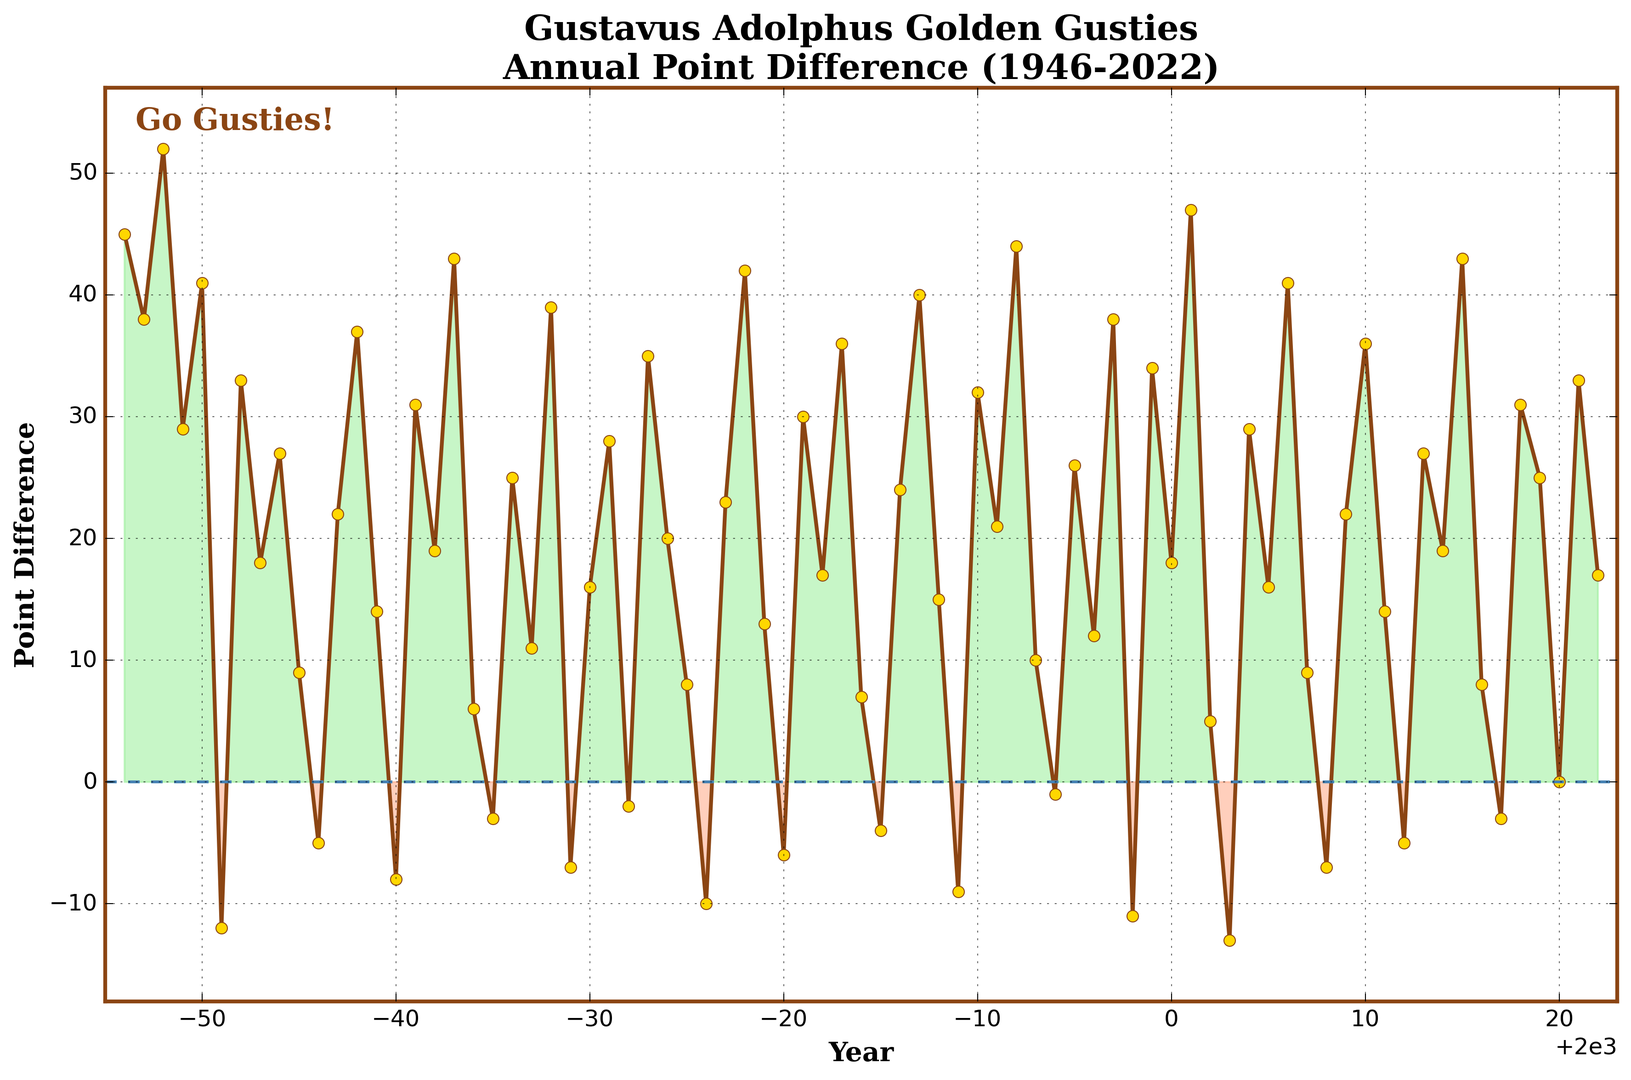What was the highest annual point difference achieved by the Gustavus Adolphus Golden Gusties from 1946 to 2022? Identify the highest point on the line chart and note the value. The highest point difference is in the year 2001 with a value of 47.
Answer: 47 Which years did the Gustavus Adolphus Golden Gusties have a negative point difference? Look for years where the line chart is below the zero-point line (indicated by shading in red). These years are 1951, 1956, 1960, 1965, 1969, 1972, 1976, 1980, 1985, 1989, 1994, 1998, 2003, 2008, 2012, and 2017.
Answer: 16 What is the average point difference from 1960 to 1970? List the point differences for each year within the range and calculate their average: (-8 + 31 + 19 + 43 + 6 + -3 + 25 + 11 + 39 + -7 + 16) / 11 = 15.91.
Answer: 15.91 In which years did the Gustavus Adolphus Golden Gusties have exactly zero point difference? Identify the year where the point difference is zero. This occurs in 2020.
Answer: 1 How many times did the point difference exceed 40? Count the peaks in the chart that exceed the 40-point difference line. These years are 1948, 1950, 1963, 2001, 2006, 2021.
Answer: 6 What is the difference between the highest positive point difference and the lowest negative point difference? Identify the highest positive (2001, 47) and the lowest negative (2003, -13) point differences and subtract the negative from the positive value: 47 - (-13) = 60.
Answer: 60 Which year had the greatest one-year increase in point difference? Compare point differences of consecutive years and find the greatest increase. From 2000 to 2001, there was an increase from 18 to 47, an increase of 29.
Answer: 2001 Was there any period of consecutive years where the point difference remained negative? Check for segments of the line chart that remain in the red zone for multiple continuous years. No such period exists where the point difference is negative for consecutive years based on the given data.
Answer: No On average, how did the point differences compare between the decades of the 1940s and the 2000s? Calculate the averages for each decade and compare: 
For the 1940s (1946-1949): (45 + 38 + 52 + 29) / 4 = 41.
For the 2000s (2000-2009): (18 + 47 + 5 + -13 + 29 + 16 + 41 + 9 + -7 + 22) / 10 = 16.9.
Answer: 41 vs 16.9 Which year had the smallest positive point difference? Look for the smallest point above the zero line (green zone) in the chart. The smallest positive point difference is in 2002 with a value of 5.
Answer: 5 